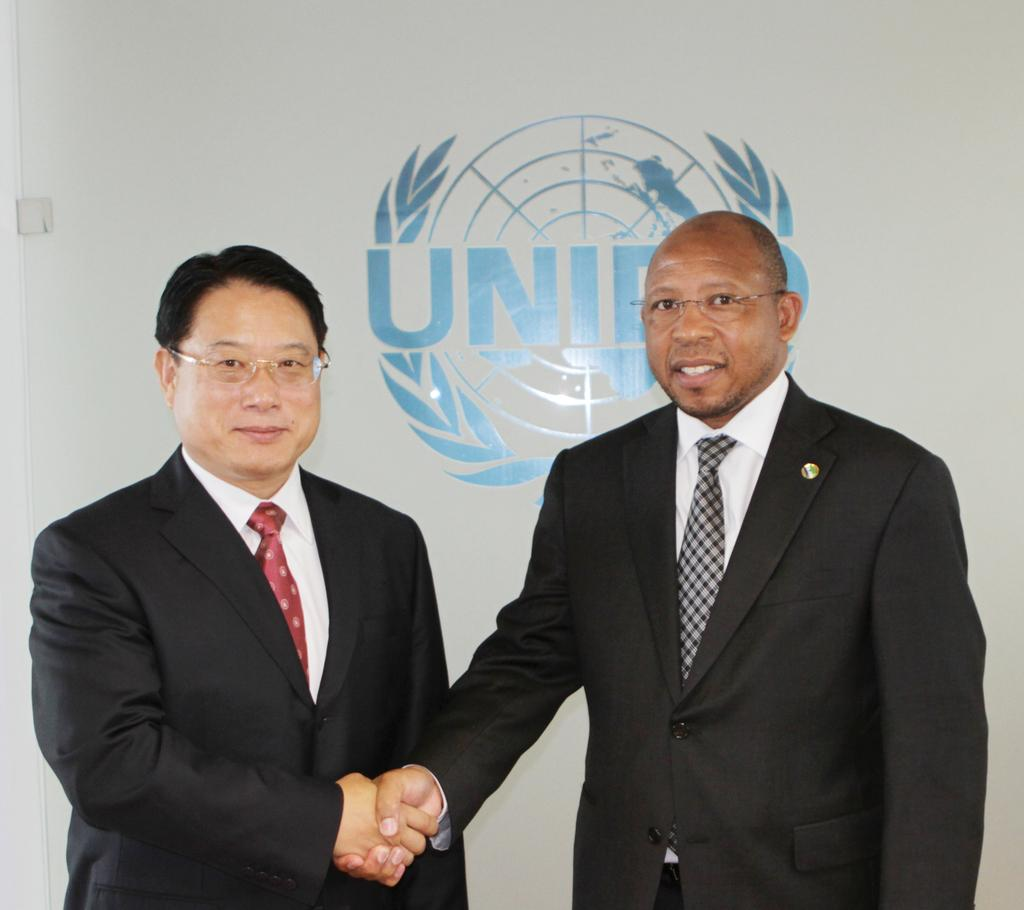How many people are in the image? There are two men in the image. What are the men doing in the image? The men are standing and smiling, and they are shaking hands. What can be seen in the background of the image? There is a logo and text on a white surface in the background of the image. What type of nail polish is the man wearing on his finger in the image? There is no mention of nail polish or fingers in the image; the men are shaking hands. Can you see a snake in the image? There is no snake present in the image. 